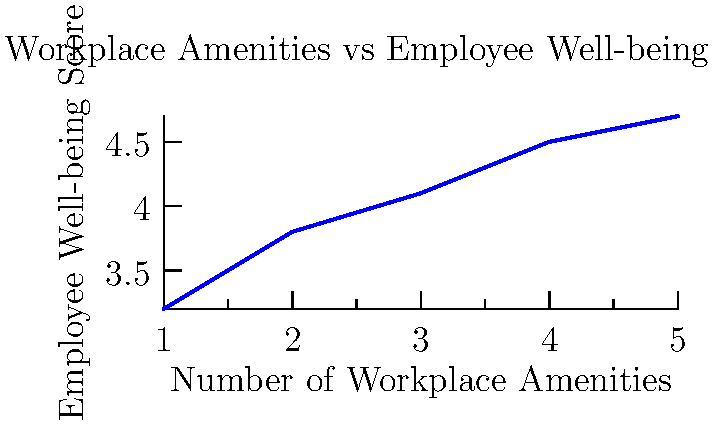Based on the infographic showing the relationship between workplace amenities and employee well-being scores, what is the approximate increase in employee well-being score when the number of workplace amenities increases from 2 to 4? To solve this question, we need to follow these steps:

1. Identify the well-being scores corresponding to 2 and 4 amenities:
   - At 2 amenities, the well-being score is approximately 3.8
   - At 4 amenities, the well-being score is approximately 4.5

2. Calculate the difference between these two scores:
   $4.5 - 3.8 = 0.7$

3. Round the result to one decimal place for approximation.

Therefore, the approximate increase in employee well-being score when the number of workplace amenities increases from 2 to 4 is 0.7.
Answer: 0.7 